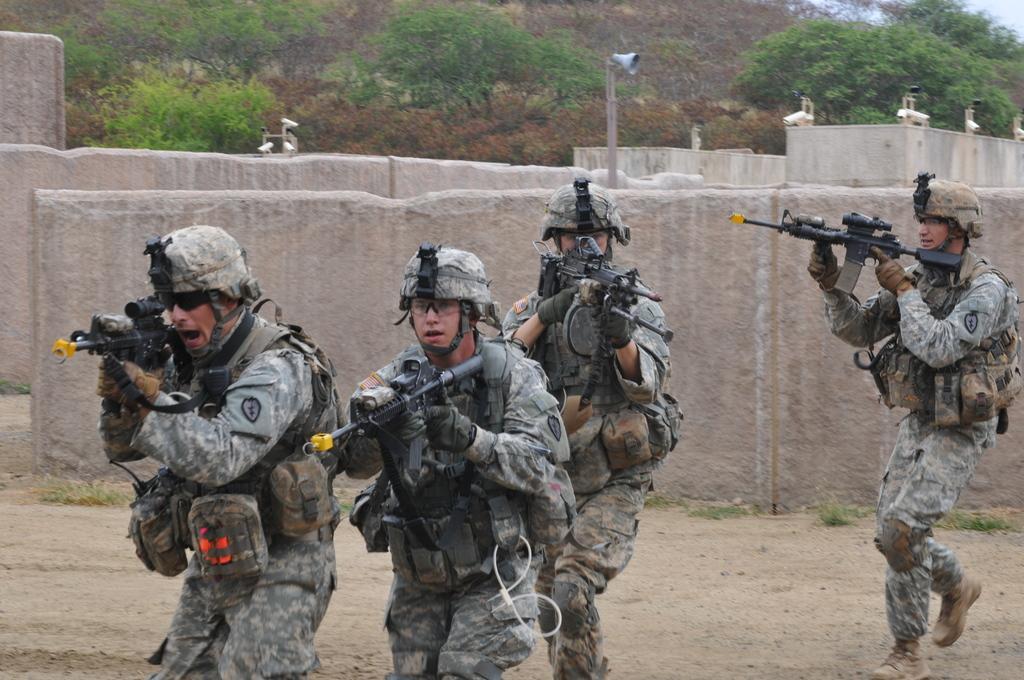In one or two sentences, can you explain what this image depicts? In this picture we can see a few people are holding guns in their hands. We can see some plants on the path. There are walls. We can see a loud speaker and other devices. Few trees are visible in the background. 